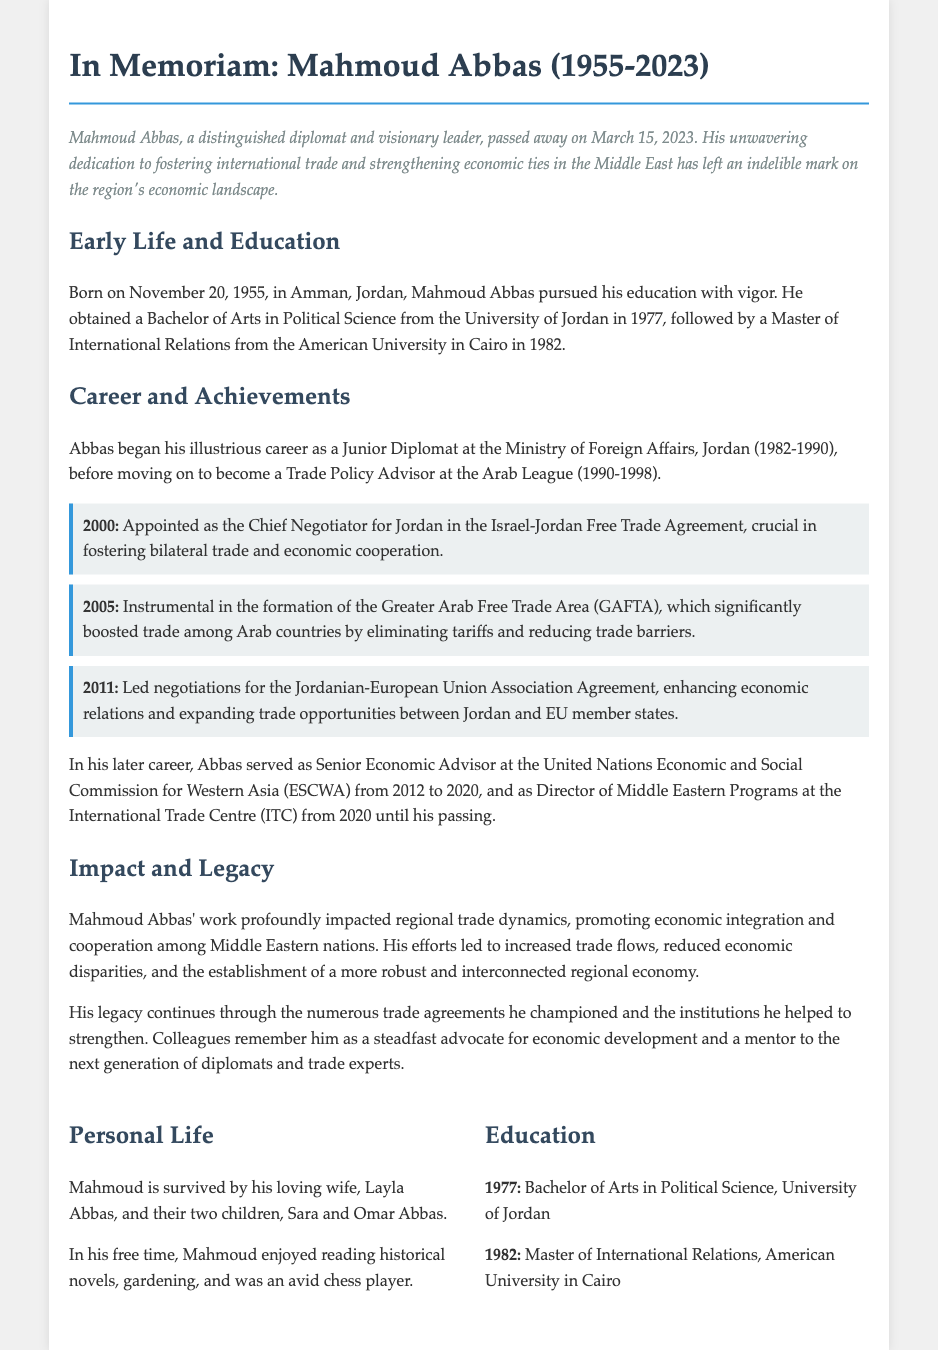What was Mahmoud Abbas's date of birth? The document states that Mahmoud Abbas was born on November 20, 1955.
Answer: November 20, 1955 What position did Abbas hold at the Arab League? The document mentions that he was a Trade Policy Advisor at the Arab League from 1990 to 1998.
Answer: Trade Policy Advisor Which agreement did Abbas negotiate in 2000? The document notes that he was appointed as the Chief Negotiator for the Israel-Jordan Free Trade Agreement in 2000.
Answer: Israel-Jordan Free Trade Agreement What did GAFTA stand for? The text indicates that GAFTA refers to the Greater Arab Free Trade Area, which was established in 2005.
Answer: Greater Arab Free Trade Area What year did Mahmoud Abbas pass away? The document clearly states that he passed away on March 15, 2023.
Answer: March 15, 2023 What legacy did Abbas leave regarding regional trade? The document highlights that his work led to increased trade flows and reduced economic disparities in the region.
Answer: Increased trade flows How many children did Mahmoud Abbas have? It is mentioned in the personal life section that he had two children, Sara and Omar Abbas.
Answer: Two children Which university did Abbas attend for his master's degree? The document states that he obtained his Master of International Relations from the American University in Cairo.
Answer: American University in Cairo What were Abbas's hobbies mentioned in the obituary? It states that he enjoyed reading historical novels, gardening, and playing chess in his free time.
Answer: Reading, gardening, chess 